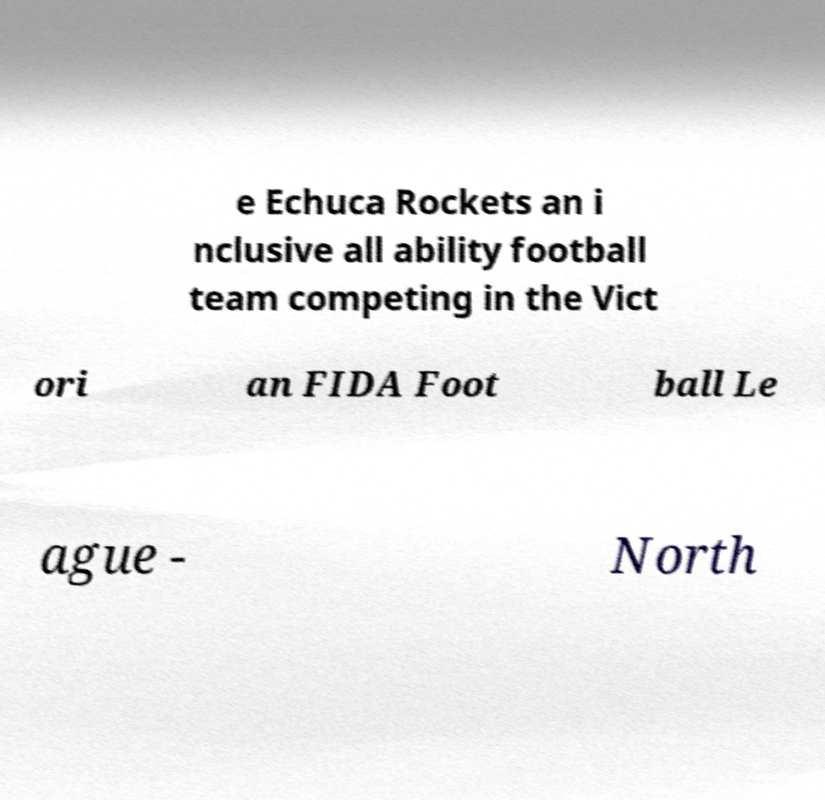Can you accurately transcribe the text from the provided image for me? e Echuca Rockets an i nclusive all ability football team competing in the Vict ori an FIDA Foot ball Le ague - North 